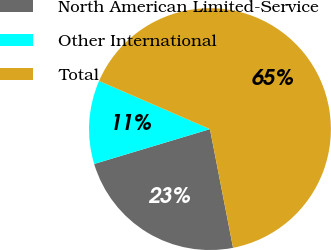<chart> <loc_0><loc_0><loc_500><loc_500><pie_chart><fcel>North American Limited-Service<fcel>Other International<fcel>Total<nl><fcel>23.41%<fcel>11.17%<fcel>65.42%<nl></chart> 